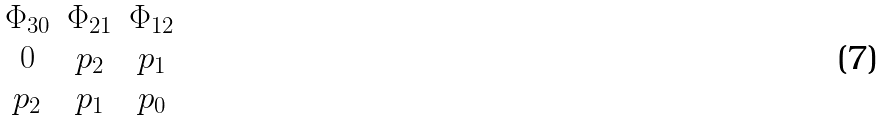<formula> <loc_0><loc_0><loc_500><loc_500>\begin{matrix} \Phi _ { 3 0 } & \Phi _ { 2 1 } & \Phi _ { 1 2 } \\ 0 & p _ { 2 } & p _ { 1 } \\ p _ { 2 } & p _ { 1 } & p _ { 0 } \end{matrix}</formula> 